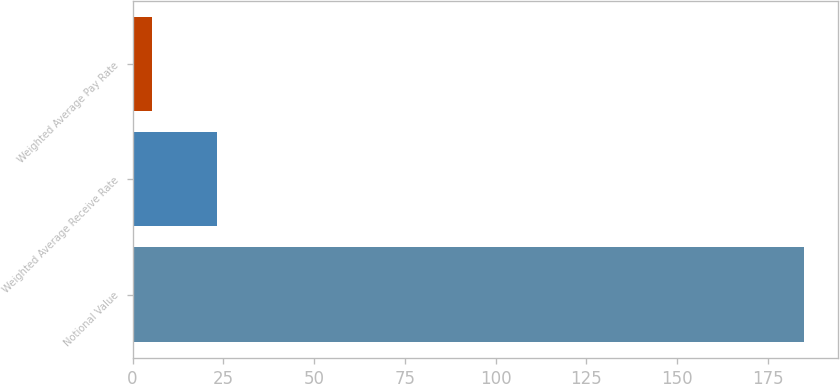Convert chart to OTSL. <chart><loc_0><loc_0><loc_500><loc_500><bar_chart><fcel>Notional Value<fcel>Weighted Average Receive Rate<fcel>Weighted Average Pay Rate<nl><fcel>185<fcel>23.32<fcel>5.36<nl></chart> 